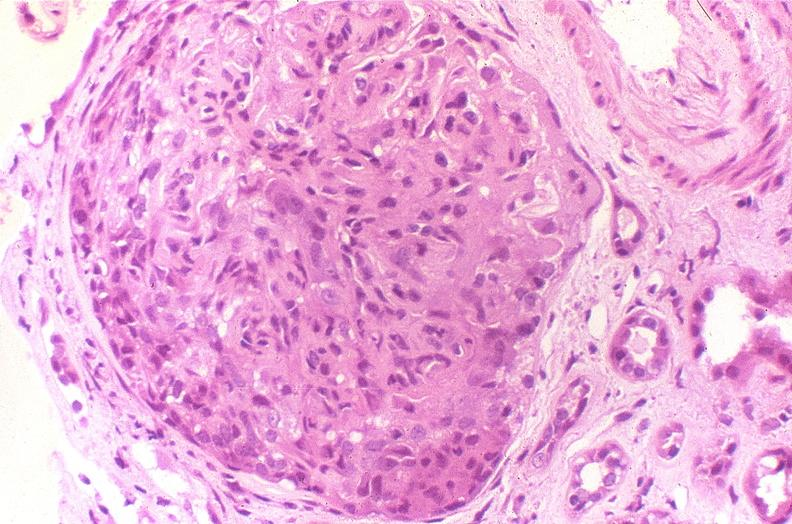s quite good example of hypopharyngeal edema larynx present?
Answer the question using a single word or phrase. No 